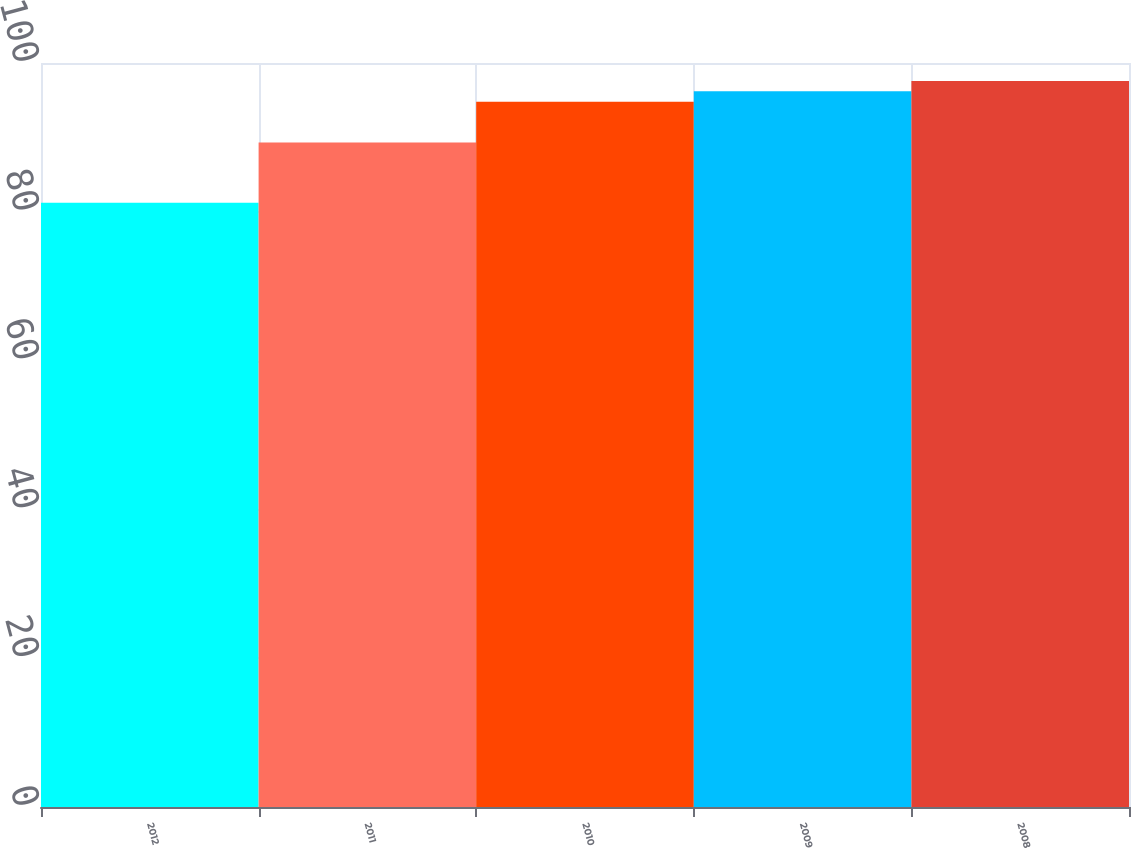Convert chart. <chart><loc_0><loc_0><loc_500><loc_500><bar_chart><fcel>2012<fcel>2011<fcel>2010<fcel>2009<fcel>2008<nl><fcel>81.2<fcel>89.3<fcel>94.8<fcel>96.19<fcel>97.58<nl></chart> 